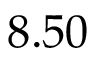<formula> <loc_0><loc_0><loc_500><loc_500>8 . 5 0</formula> 